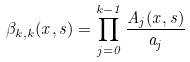<formula> <loc_0><loc_0><loc_500><loc_500>\beta _ { k , k } ( x , s ) = \prod _ { j = 0 } ^ { k - 1 } \frac { A _ { j } ( x , s ) } { a _ { j } }</formula> 